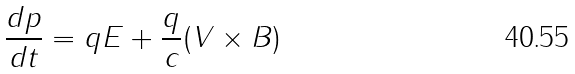Convert formula to latex. <formula><loc_0><loc_0><loc_500><loc_500>\frac { d p } { d t } = q E + \frac { q } { c } ( V \times B )</formula> 